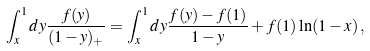<formula> <loc_0><loc_0><loc_500><loc_500>\int _ { x } ^ { 1 } d y \frac { f ( y ) } { ( 1 - y ) _ { + } } = \int _ { x } ^ { 1 } d y \frac { f ( y ) - f ( 1 ) } { 1 - y } + f ( 1 ) \ln ( 1 - x ) \, ,</formula> 